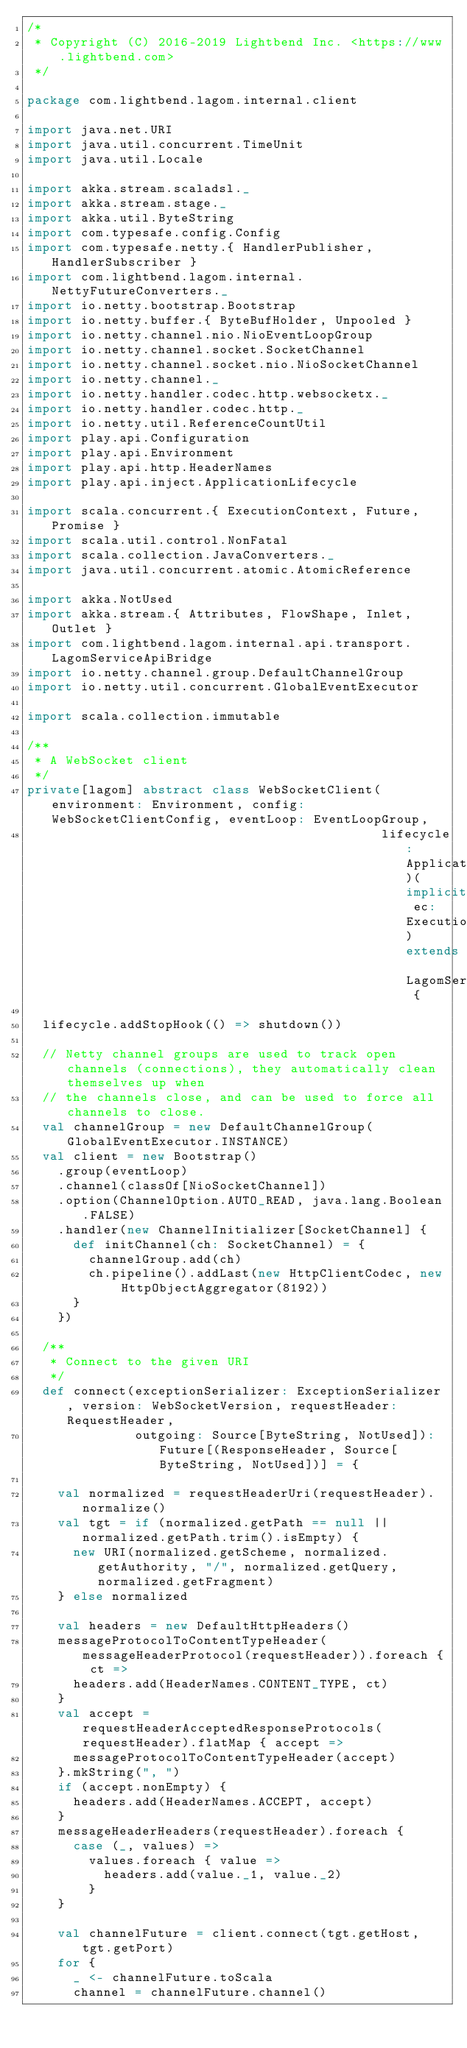Convert code to text. <code><loc_0><loc_0><loc_500><loc_500><_Scala_>/*
 * Copyright (C) 2016-2019 Lightbend Inc. <https://www.lightbend.com>
 */

package com.lightbend.lagom.internal.client

import java.net.URI
import java.util.concurrent.TimeUnit
import java.util.Locale

import akka.stream.scaladsl._
import akka.stream.stage._
import akka.util.ByteString
import com.typesafe.config.Config
import com.typesafe.netty.{ HandlerPublisher, HandlerSubscriber }
import com.lightbend.lagom.internal.NettyFutureConverters._
import io.netty.bootstrap.Bootstrap
import io.netty.buffer.{ ByteBufHolder, Unpooled }
import io.netty.channel.nio.NioEventLoopGroup
import io.netty.channel.socket.SocketChannel
import io.netty.channel.socket.nio.NioSocketChannel
import io.netty.channel._
import io.netty.handler.codec.http.websocketx._
import io.netty.handler.codec.http._
import io.netty.util.ReferenceCountUtil
import play.api.Configuration
import play.api.Environment
import play.api.http.HeaderNames
import play.api.inject.ApplicationLifecycle

import scala.concurrent.{ ExecutionContext, Future, Promise }
import scala.util.control.NonFatal
import scala.collection.JavaConverters._
import java.util.concurrent.atomic.AtomicReference

import akka.NotUsed
import akka.stream.{ Attributes, FlowShape, Inlet, Outlet }
import com.lightbend.lagom.internal.api.transport.LagomServiceApiBridge
import io.netty.channel.group.DefaultChannelGroup
import io.netty.util.concurrent.GlobalEventExecutor

import scala.collection.immutable

/**
 * A WebSocket client
 */
private[lagom] abstract class WebSocketClient(environment: Environment, config: WebSocketClientConfig, eventLoop: EventLoopGroup,
                                              lifecycle: ApplicationLifecycle)(implicit ec: ExecutionContext) extends LagomServiceApiBridge {

  lifecycle.addStopHook(() => shutdown())

  // Netty channel groups are used to track open channels (connections), they automatically clean themselves up when
  // the channels close, and can be used to force all channels to close.
  val channelGroup = new DefaultChannelGroup(GlobalEventExecutor.INSTANCE)
  val client = new Bootstrap()
    .group(eventLoop)
    .channel(classOf[NioSocketChannel])
    .option(ChannelOption.AUTO_READ, java.lang.Boolean.FALSE)
    .handler(new ChannelInitializer[SocketChannel] {
      def initChannel(ch: SocketChannel) = {
        channelGroup.add(ch)
        ch.pipeline().addLast(new HttpClientCodec, new HttpObjectAggregator(8192))
      }
    })

  /**
   * Connect to the given URI
   */
  def connect(exceptionSerializer: ExceptionSerializer, version: WebSocketVersion, requestHeader: RequestHeader,
              outgoing: Source[ByteString, NotUsed]): Future[(ResponseHeader, Source[ByteString, NotUsed])] = {

    val normalized = requestHeaderUri(requestHeader).normalize()
    val tgt = if (normalized.getPath == null || normalized.getPath.trim().isEmpty) {
      new URI(normalized.getScheme, normalized.getAuthority, "/", normalized.getQuery, normalized.getFragment)
    } else normalized

    val headers = new DefaultHttpHeaders()
    messageProtocolToContentTypeHeader(messageHeaderProtocol(requestHeader)).foreach { ct =>
      headers.add(HeaderNames.CONTENT_TYPE, ct)
    }
    val accept = requestHeaderAcceptedResponseProtocols(requestHeader).flatMap { accept =>
      messageProtocolToContentTypeHeader(accept)
    }.mkString(", ")
    if (accept.nonEmpty) {
      headers.add(HeaderNames.ACCEPT, accept)
    }
    messageHeaderHeaders(requestHeader).foreach {
      case (_, values) =>
        values.foreach { value =>
          headers.add(value._1, value._2)
        }
    }

    val channelFuture = client.connect(tgt.getHost, tgt.getPort)
    for {
      _ <- channelFuture.toScala
      channel = channelFuture.channel()</code> 